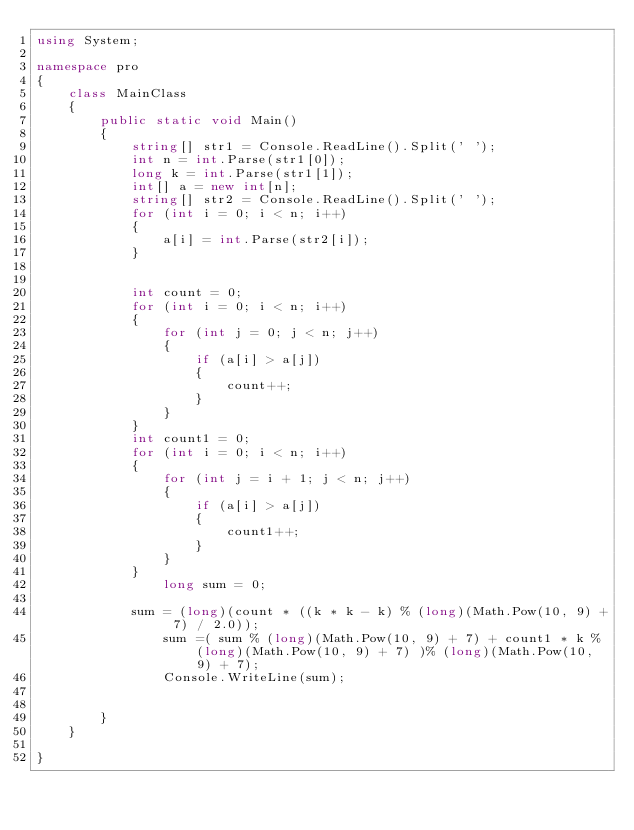<code> <loc_0><loc_0><loc_500><loc_500><_C#_>using System;

namespace pro
{
    class MainClass
    {
        public static void Main()
        {
            string[] str1 = Console.ReadLine().Split(' ');
            int n = int.Parse(str1[0]);
            long k = int.Parse(str1[1]);
            int[] a = new int[n];
            string[] str2 = Console.ReadLine().Split(' ');
            for (int i = 0; i < n; i++)
            {
                a[i] = int.Parse(str2[i]);
            }


            int count = 0;
            for (int i = 0; i < n; i++)
            {
                for (int j = 0; j < n; j++)
                {
                    if (a[i] > a[j])
                    {
                        count++;
                    }
                }
            }
            int count1 = 0;
            for (int i = 0; i < n; i++)
            {
                for (int j = i + 1; j < n; j++)
                {
                    if (a[i] > a[j])
                    {
                        count1++;
                    }
                }
            }
                long sum = 0;

            sum = (long)(count * ((k * k - k) % (long)(Math.Pow(10, 9) + 7) / 2.0));
                sum =( sum % (long)(Math.Pow(10, 9) + 7) + count1 * k % (long)(Math.Pow(10, 9) + 7) )% (long)(Math.Pow(10, 9) + 7);
                Console.WriteLine(sum);
            

        }
    }

}</code> 